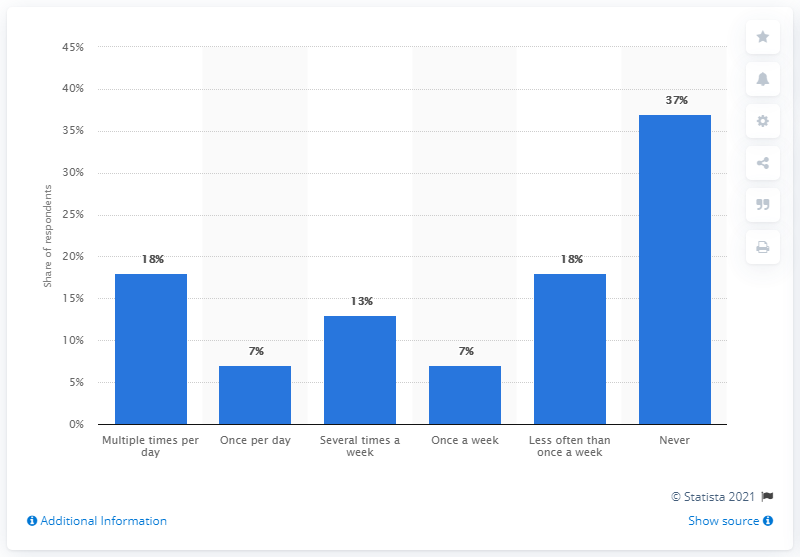Give some essential details in this illustration. A small percentage of people never use the group chat function of text messaging or online messaging applications. It is estimated that approximately 7% of people use the group chat function of text messaging (SMS) or online messaging applications on a daily basis. 